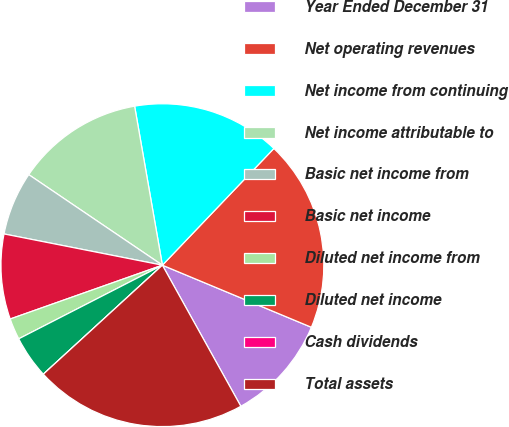<chart> <loc_0><loc_0><loc_500><loc_500><pie_chart><fcel>Year Ended December 31<fcel>Net operating revenues<fcel>Net income from continuing<fcel>Net income attributable to<fcel>Basic net income from<fcel>Basic net income<fcel>Diluted net income from<fcel>Diluted net income<fcel>Cash dividends<fcel>Total assets<nl><fcel>10.64%<fcel>19.15%<fcel>14.89%<fcel>12.77%<fcel>6.38%<fcel>8.51%<fcel>2.13%<fcel>4.26%<fcel>0.0%<fcel>21.28%<nl></chart> 